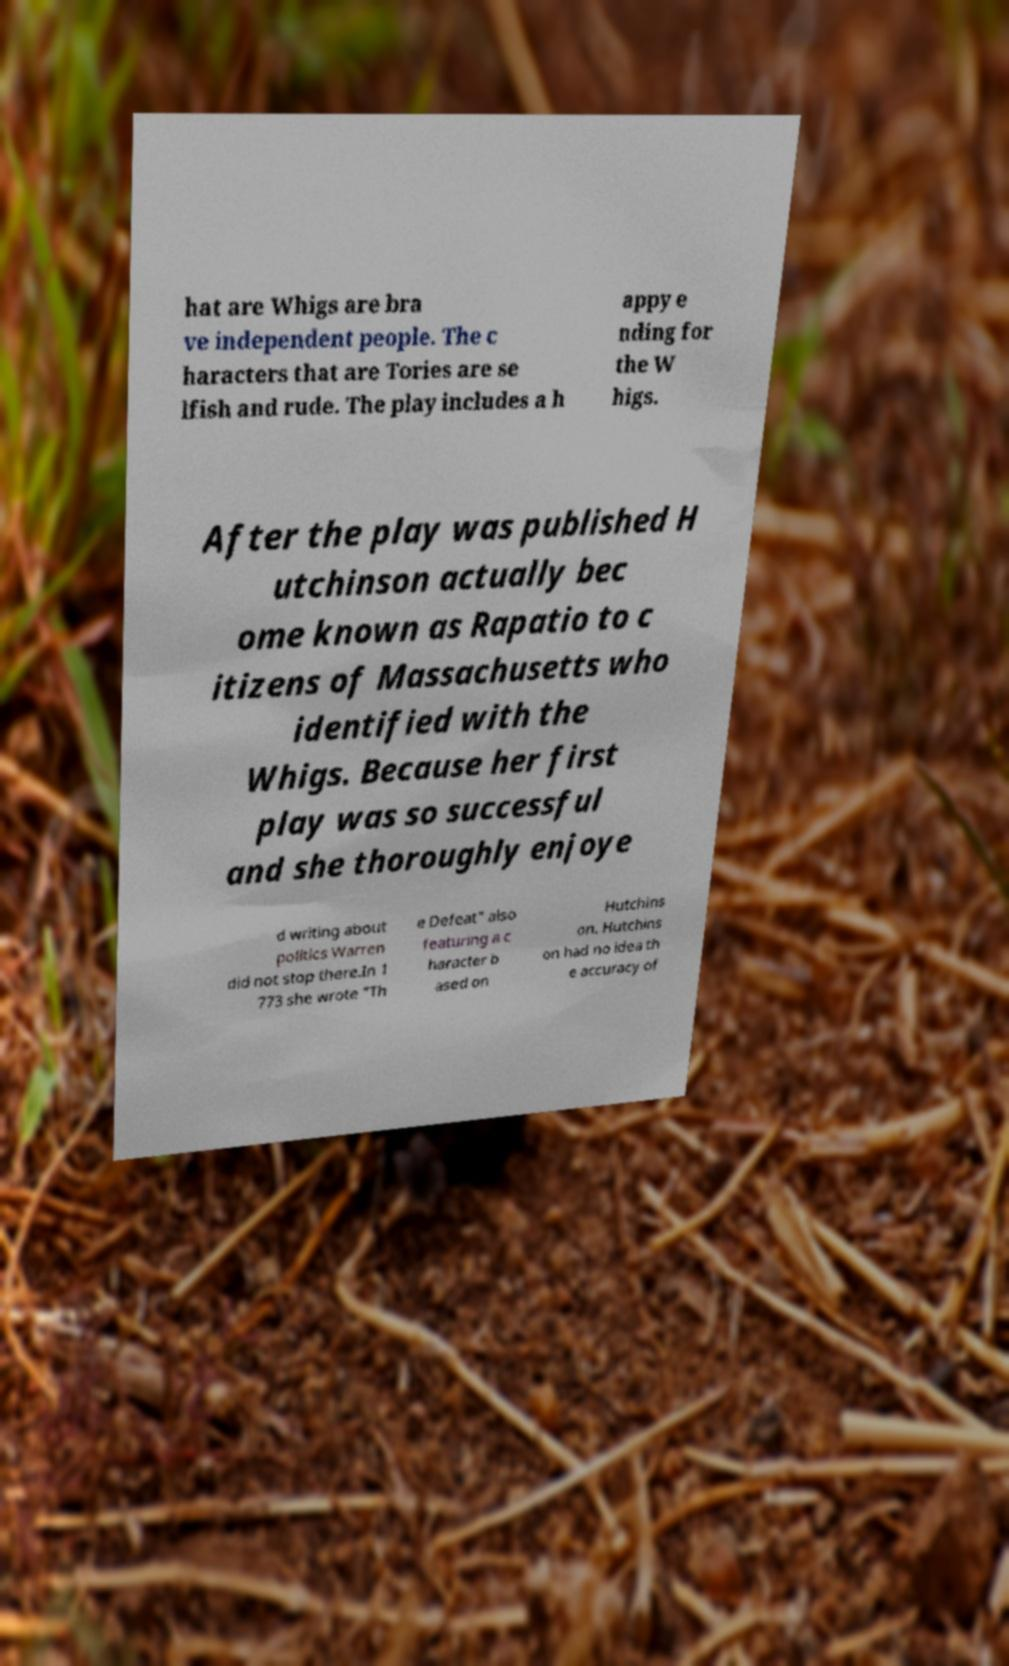Can you accurately transcribe the text from the provided image for me? hat are Whigs are bra ve independent people. The c haracters that are Tories are se lfish and rude. The play includes a h appy e nding for the W higs. After the play was published H utchinson actually bec ome known as Rapatio to c itizens of Massachusetts who identified with the Whigs. Because her first play was so successful and she thoroughly enjoye d writing about politics Warren did not stop there.In 1 773 she wrote "Th e Defeat" also featuring a c haracter b ased on Hutchins on. Hutchins on had no idea th e accuracy of 